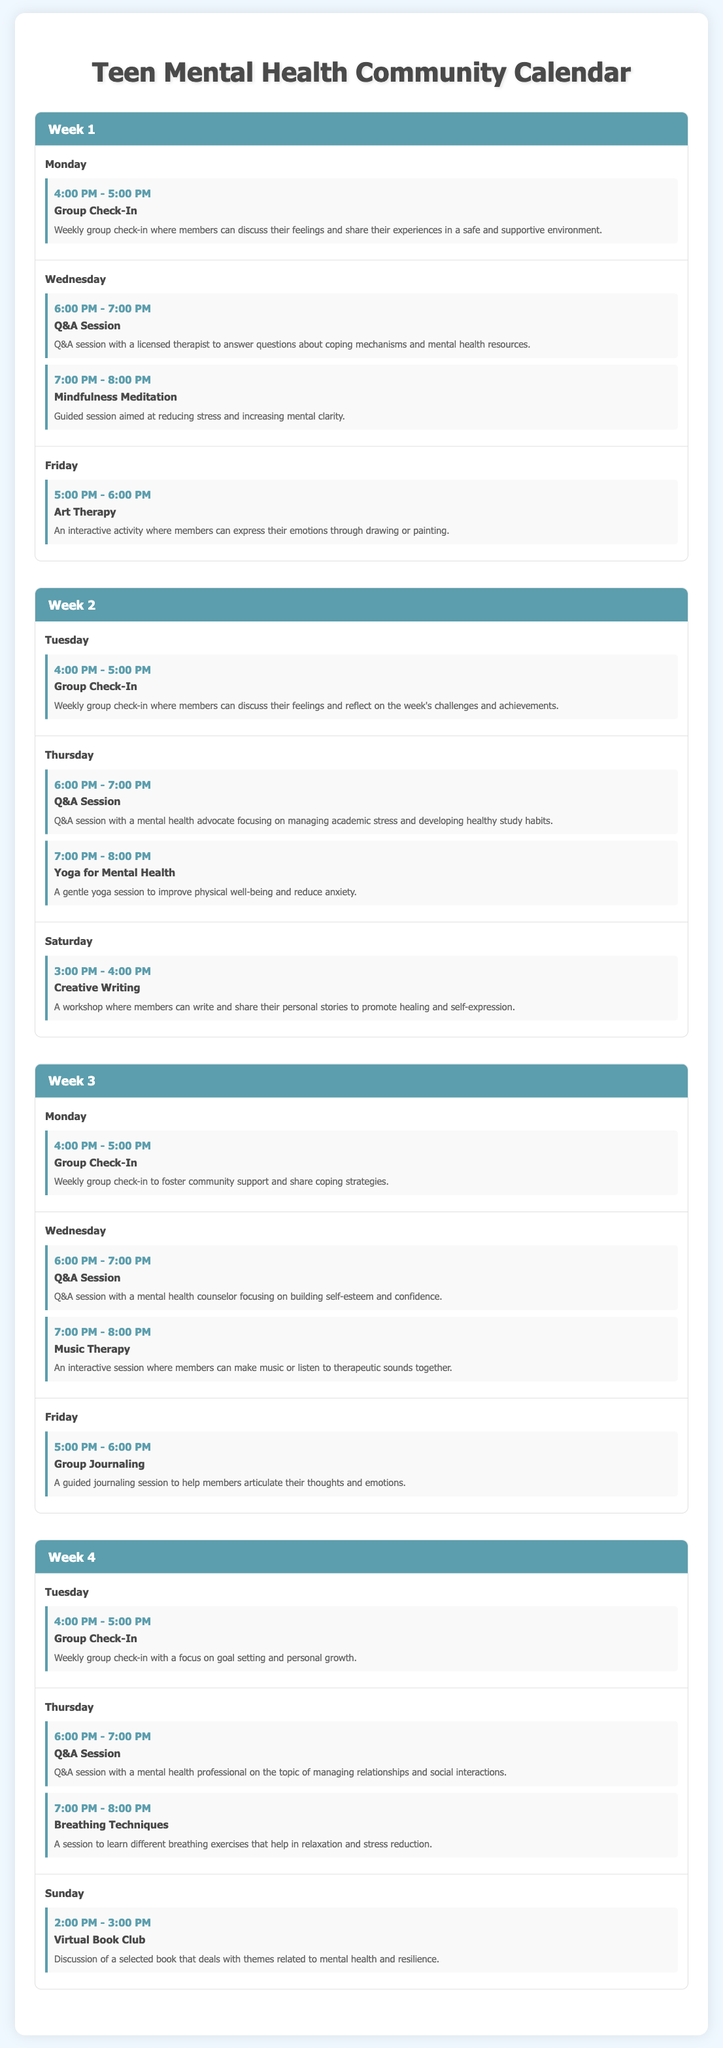What takes place on Monday of Week 1? The event listed for Monday of Week 1 is a Group Check-In, which is scheduled from 4:00 PM to 5:00 PM.
Answer: Group Check-In What is the time of the Q&A session in Week 2? The document states that the Q&A session in Week 2 occurs on Thursday from 6:00 PM to 7:00 PM.
Answer: 6:00 PM - 7:00 PM How many events are scheduled on Wednesday of Week 3? On Wednesday of Week 3, there are two events listed: the Q&A Session and Music Therapy, meaning a total of two events.
Answer: 2 What activity is scheduled for Saturday of Week 2? The scheduled activity for Saturday of Week 2 is Creative Writing, which takes place from 3:00 PM to 4:00 PM.
Answer: Creative Writing Which day features a Virtual Book Club in Week 4? The Virtual Book Club is scheduled on Sunday in Week 4, from 2:00 PM to 3:00 PM.
Answer: Sunday What type of session is offered at 7:00 PM on Wednesday of Week 1? The session at 7:00 PM on Wednesday of Week 1 is called Mindfulness Meditation.
Answer: Mindfulness Meditation Which week has a focus on goal setting during the Group Check-In? The Group Check-In focusing on goal setting takes place in Week 4 on Tuesday from 4:00 PM to 5:00 PM.
Answer: Week 4 What is the event title for the session that deals with academic stress in Week 2? The event title for the session that deals with academic stress is the Q&A Session, scheduled on Thursday from 6:00 PM to 7:00 PM.
Answer: Q&A Session 